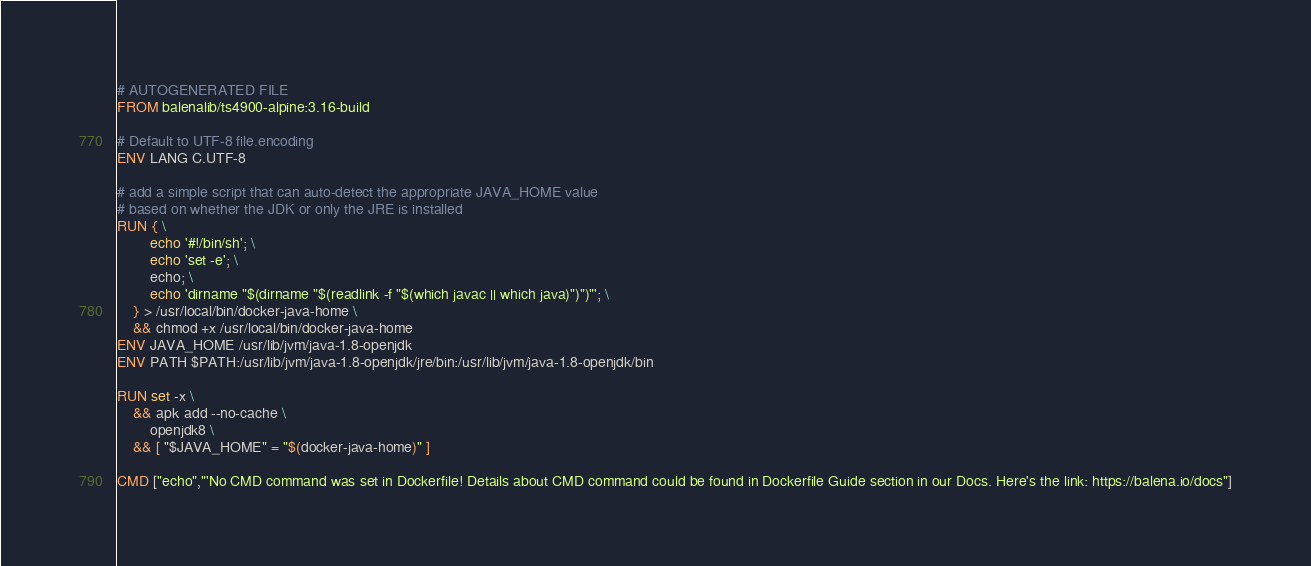Convert code to text. <code><loc_0><loc_0><loc_500><loc_500><_Dockerfile_># AUTOGENERATED FILE
FROM balenalib/ts4900-alpine:3.16-build

# Default to UTF-8 file.encoding
ENV LANG C.UTF-8

# add a simple script that can auto-detect the appropriate JAVA_HOME value
# based on whether the JDK or only the JRE is installed
RUN { \
		echo '#!/bin/sh'; \
		echo 'set -e'; \
		echo; \
		echo 'dirname "$(dirname "$(readlink -f "$(which javac || which java)")")"'; \
	} > /usr/local/bin/docker-java-home \
	&& chmod +x /usr/local/bin/docker-java-home
ENV JAVA_HOME /usr/lib/jvm/java-1.8-openjdk
ENV PATH $PATH:/usr/lib/jvm/java-1.8-openjdk/jre/bin:/usr/lib/jvm/java-1.8-openjdk/bin

RUN set -x \
	&& apk add --no-cache \
		openjdk8 \
	&& [ "$JAVA_HOME" = "$(docker-java-home)" ]

CMD ["echo","'No CMD command was set in Dockerfile! Details about CMD command could be found in Dockerfile Guide section in our Docs. Here's the link: https://balena.io/docs"]
</code> 